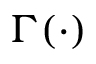<formula> <loc_0><loc_0><loc_500><loc_500>\Gamma ( \cdot )</formula> 